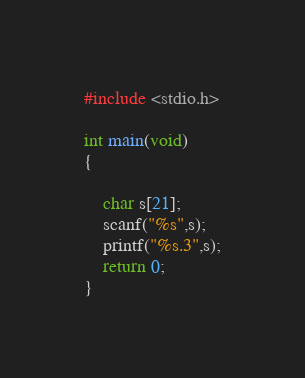Convert code to text. <code><loc_0><loc_0><loc_500><loc_500><_C_>#include <stdio.h>

int main(void)
{

    char s[21];
    scanf("%s",s);
    printf("%s.3",s);
    return 0;
}</code> 